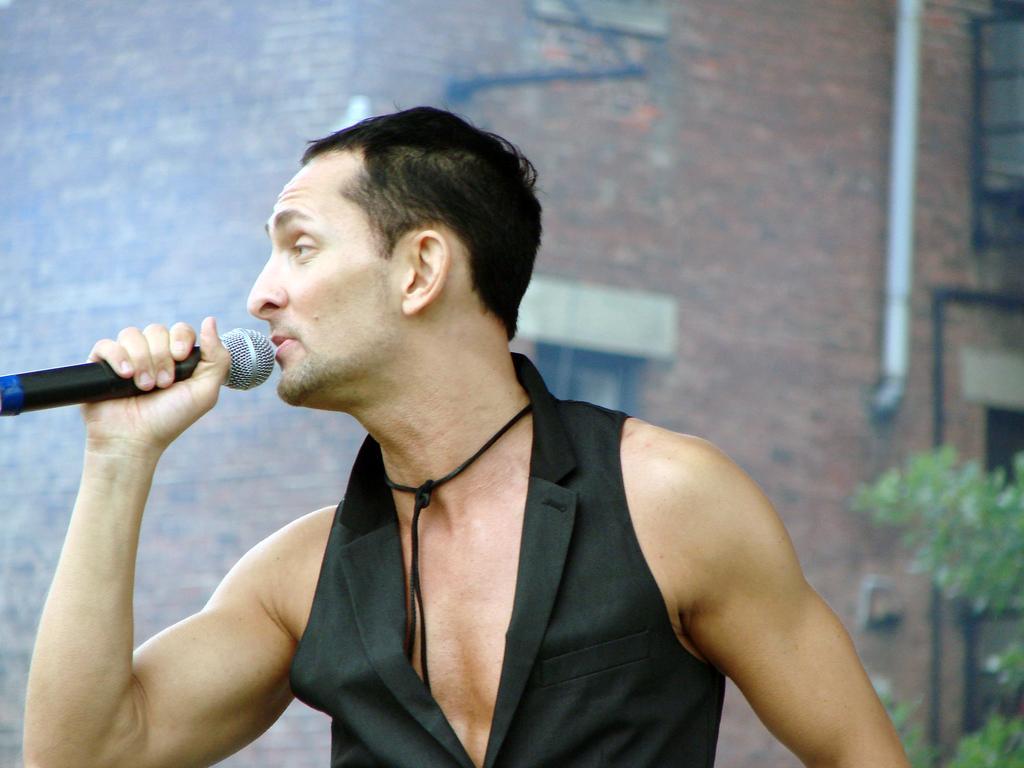In one or two sentences, can you explain what this image depicts? As we can see in the image there is a man holding mic. 